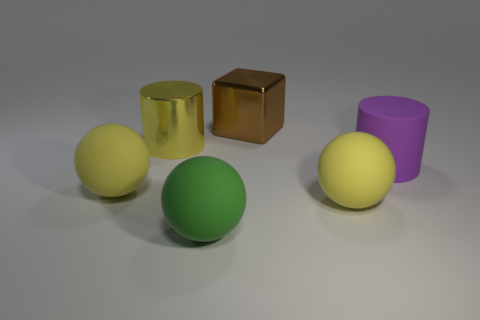Add 3 big metal blocks. How many objects exist? 9 Subtract all cylinders. How many objects are left? 4 Add 6 large shiny cylinders. How many large shiny cylinders exist? 7 Subtract 0 brown cylinders. How many objects are left? 6 Subtract all green matte spheres. Subtract all green matte spheres. How many objects are left? 4 Add 3 shiny cylinders. How many shiny cylinders are left? 4 